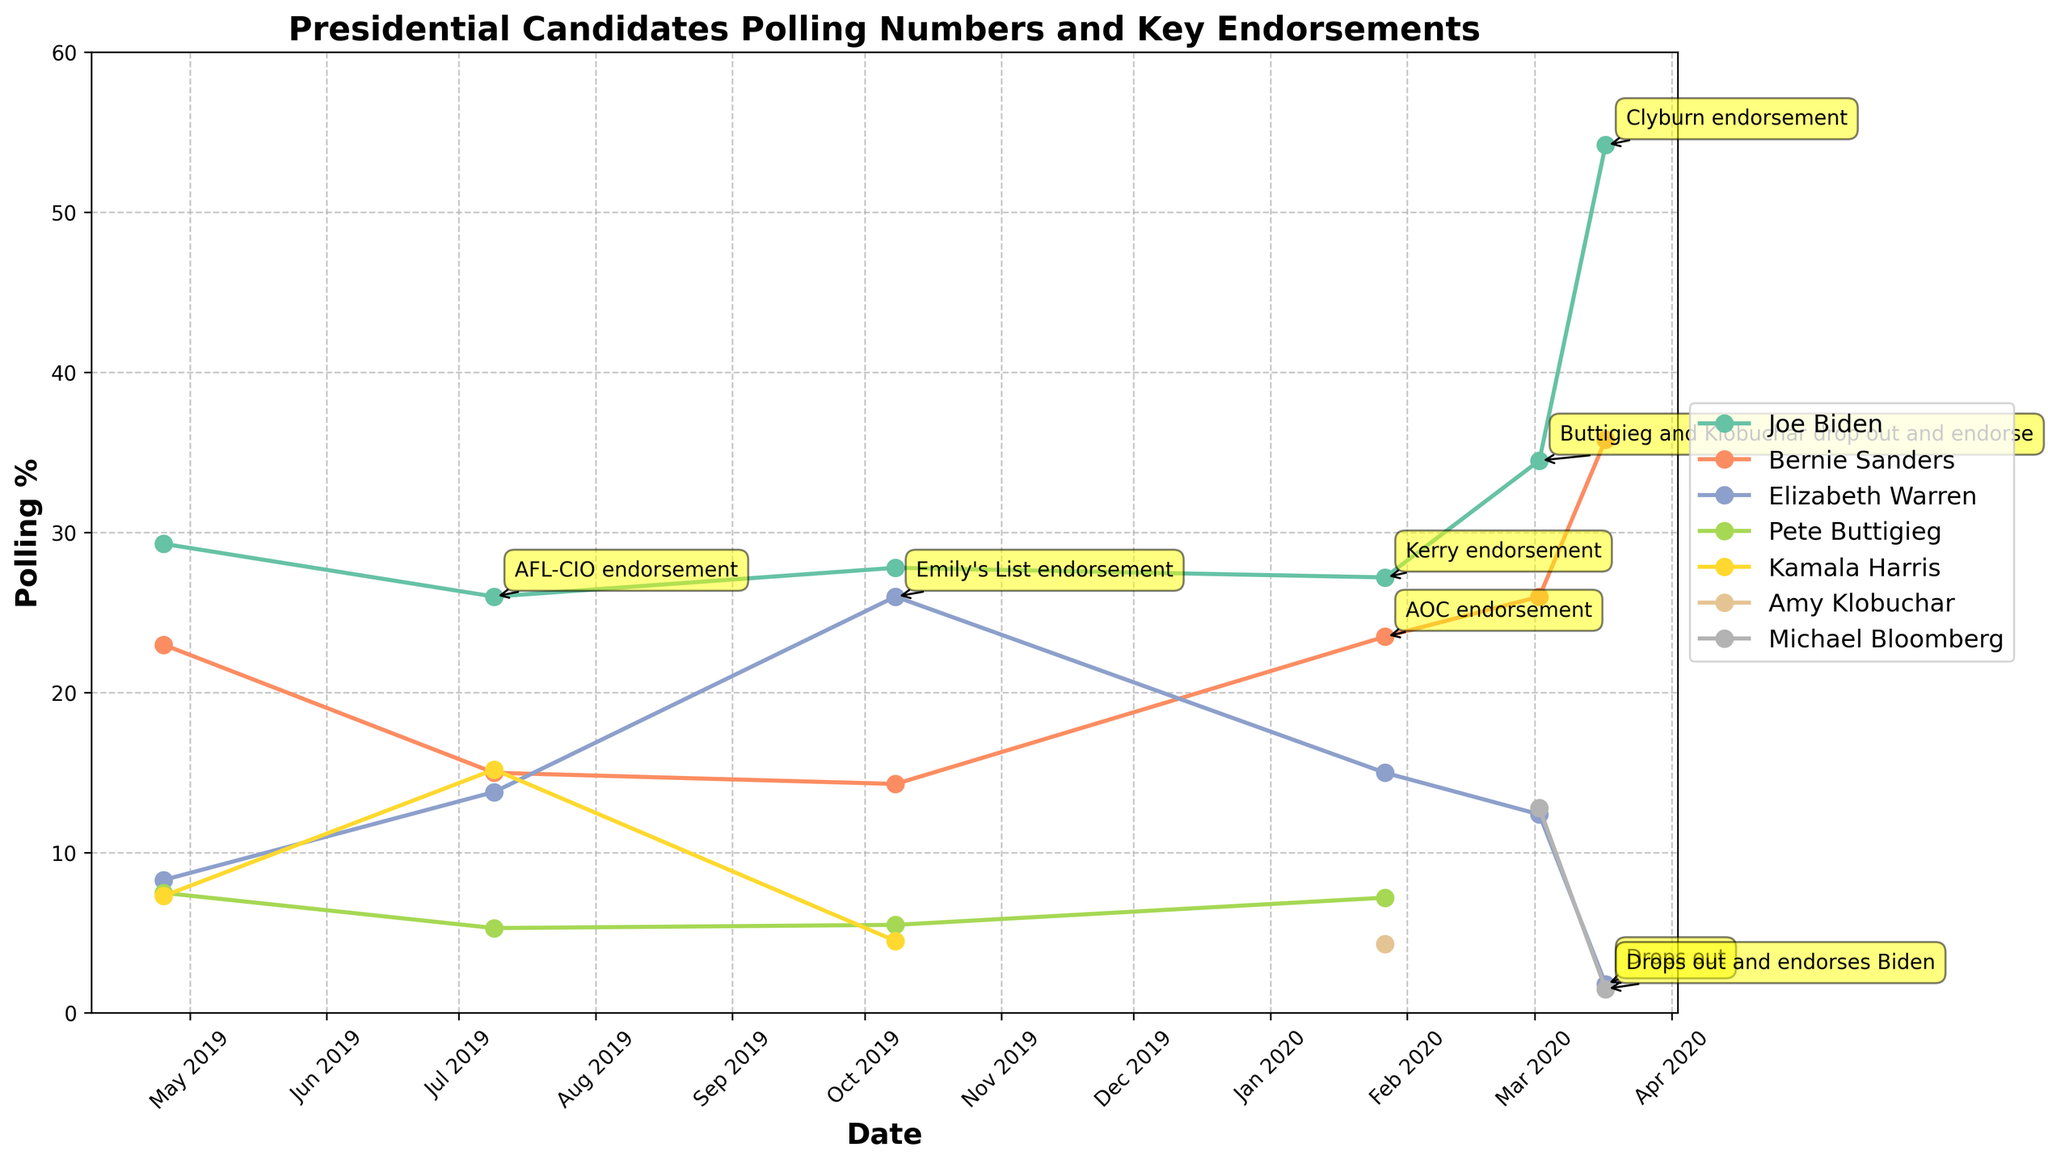What was Joe Biden's polling percentage on March 17, 2020, and did he receive any endorsement on that date? Look at the point for Joe Biden on March 17, 2020, and check for any annotations about endorsements. Biden's polling percentage was 54.2%, and he received the Clyburn endorsement.
Answer: 54.2%, Clyburn endorsement Compare the polling percentages of Bernie Sanders and Elizabeth Warren on October 8, 2019. Who had the higher polling percentage? Identify the points for Bernie Sanders and Elizabeth Warren on October 8, 2019. Sanders had a polling percentage of 14.3%, and Warren had 26%. Warren had the higher polling percentage.
Answer: Elizabeth Warren What trend can be observed in Joe Biden's polling percentages from July 9, 2019, to March 17, 2020? Trace the polling percentages for Joe Biden between the mentioned dates. His polling percentages were 26% (July 9, 2019), 27.8% (October 8, 2019), 27.2% (January 27, 2020), 34.5% (March 2, 2020), and 54.2% (March 17, 2020). There is an overall increasing trend in Joe Biden's polling percentages.
Answer: Increasing trend Which candidate had a significant rise in polling percentage after receiving an endorsement on January 27, 2020? Check all candidates' polling percentages around January 27, 2020, and identify who received endorsements. Bernie Sanders received the AOC endorsement and saw his polling percentage rise to 23.5% from prior lower values.
Answer: Bernie Sanders On March 17, 2020, which candidate had the lowest polling percentage among those still in the race? Review the candidates' polling percentages on March 17, 2020, and exclude those who dropped out. Among those remaining, Michael Bloomberg had the lowest polling percentage with 1.5%.
Answer: Michael Bloomberg How did Pete Buttigieg's endorsement affect Joe Biden's polling percentage on March 2, 2020? Look at Joe Biden's polling percentage on March 2, 2020, which coincides with Buttigieg's endorsement. His polling percentage was 34.5%, indicating a significant positive effect.
Answer: Significant positive effect What was the change in Bernie Sanders' polling percentage from January 27, 2020, to March 17, 2020? Subtract Bernie Sanders’ polling percentage on January 27, 2020 (23.5%), from his polling percentage on March 17, 2020 (35.8%). The change is 35.8% - 23.5% = 12.3%.
Answer: Increase of 12.3% Which candidate had nearly equal polling percentages on October 8, 2019? Compare the polling percentages of all candidates on October 8, 2019. Elizabeth Warren (26%) and Joe Biden (27.8%) had nearly equal polling percentages.
Answer: Elizabeth Warren and Joe Biden Did Michael Bloomberg's endorsement of Joe Biden on March 17, 2020, result in an immediate drop in Bloomberg's polling percentage? Look at Michael Bloomberg’s polling percentage on March 17, 2020, and observe if there's any annotation for his endorsement. Bloomberg dropped out and endorsed Biden on March 17, and his polling percentage dropped to 1.5% on that date.
Answer: Yes 